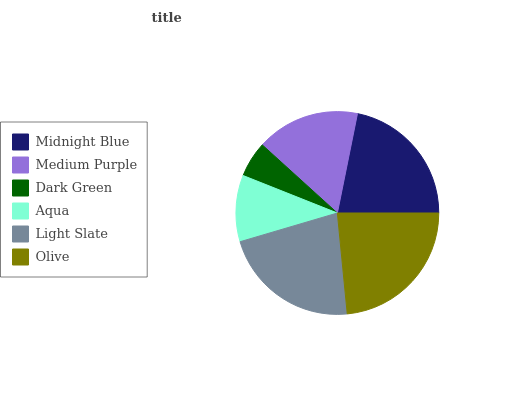Is Dark Green the minimum?
Answer yes or no. Yes. Is Olive the maximum?
Answer yes or no. Yes. Is Medium Purple the minimum?
Answer yes or no. No. Is Medium Purple the maximum?
Answer yes or no. No. Is Midnight Blue greater than Medium Purple?
Answer yes or no. Yes. Is Medium Purple less than Midnight Blue?
Answer yes or no. Yes. Is Medium Purple greater than Midnight Blue?
Answer yes or no. No. Is Midnight Blue less than Medium Purple?
Answer yes or no. No. Is Midnight Blue the high median?
Answer yes or no. Yes. Is Medium Purple the low median?
Answer yes or no. Yes. Is Light Slate the high median?
Answer yes or no. No. Is Dark Green the low median?
Answer yes or no. No. 